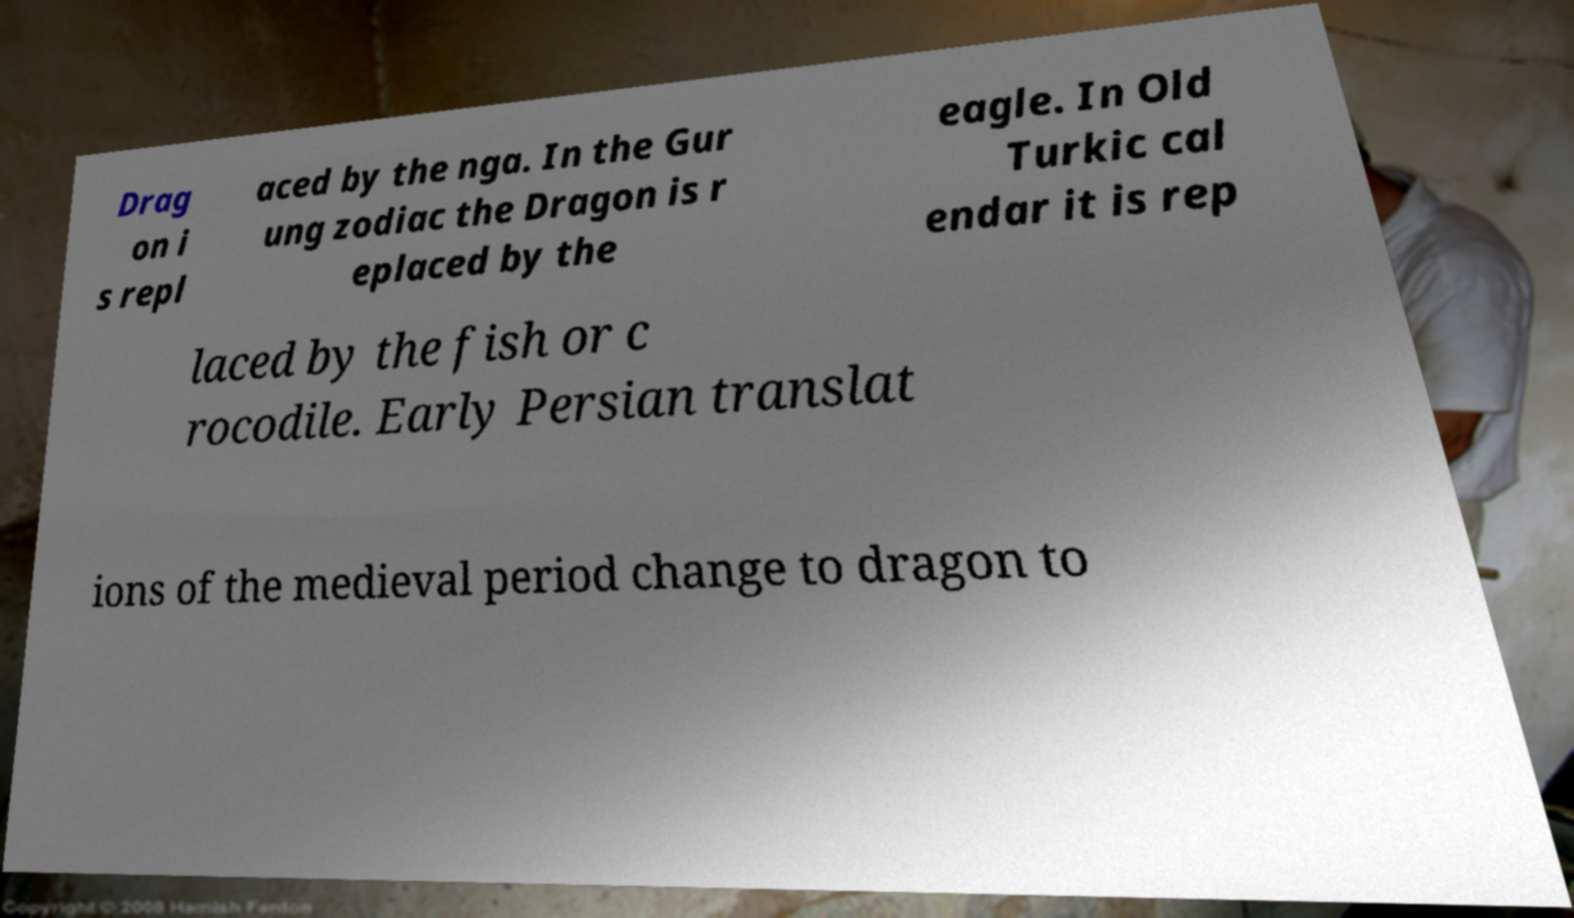What messages or text are displayed in this image? I need them in a readable, typed format. Drag on i s repl aced by the nga. In the Gur ung zodiac the Dragon is r eplaced by the eagle. In Old Turkic cal endar it is rep laced by the fish or c rocodile. Early Persian translat ions of the medieval period change to dragon to 